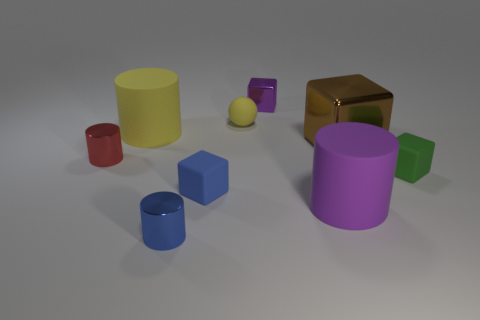How many other objects are the same shape as the blue matte object?
Ensure brevity in your answer.  3. Do the large brown thing and the tiny yellow thing have the same shape?
Ensure brevity in your answer.  No. Are there any large brown objects behind the green block?
Your answer should be compact. Yes. How many objects are large yellow matte cylinders or red cylinders?
Your response must be concise. 2. How many other objects are the same size as the yellow cylinder?
Offer a very short reply. 2. What number of things are both in front of the purple cube and behind the red thing?
Give a very brief answer. 3. There is a cylinder on the right side of the small purple thing; does it have the same size as the matte object that is on the right side of the purple cylinder?
Your answer should be compact. No. What is the size of the rubber cube to the left of the small purple block?
Provide a short and direct response. Small. How many objects are large metallic objects on the right side of the small purple metallic thing or metal blocks that are in front of the yellow ball?
Provide a short and direct response. 1. Is there any other thing of the same color as the ball?
Your answer should be compact. Yes. 